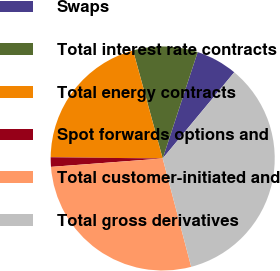Convert chart. <chart><loc_0><loc_0><loc_500><loc_500><pie_chart><fcel>Swaps<fcel>Total interest rate contracts<fcel>Total energy contracts<fcel>Spot forwards options and<fcel>Total customer-initiated and<fcel>Total gross derivatives<nl><fcel>5.97%<fcel>9.32%<fcel>20.56%<fcel>1.37%<fcel>27.9%<fcel>34.88%<nl></chart> 